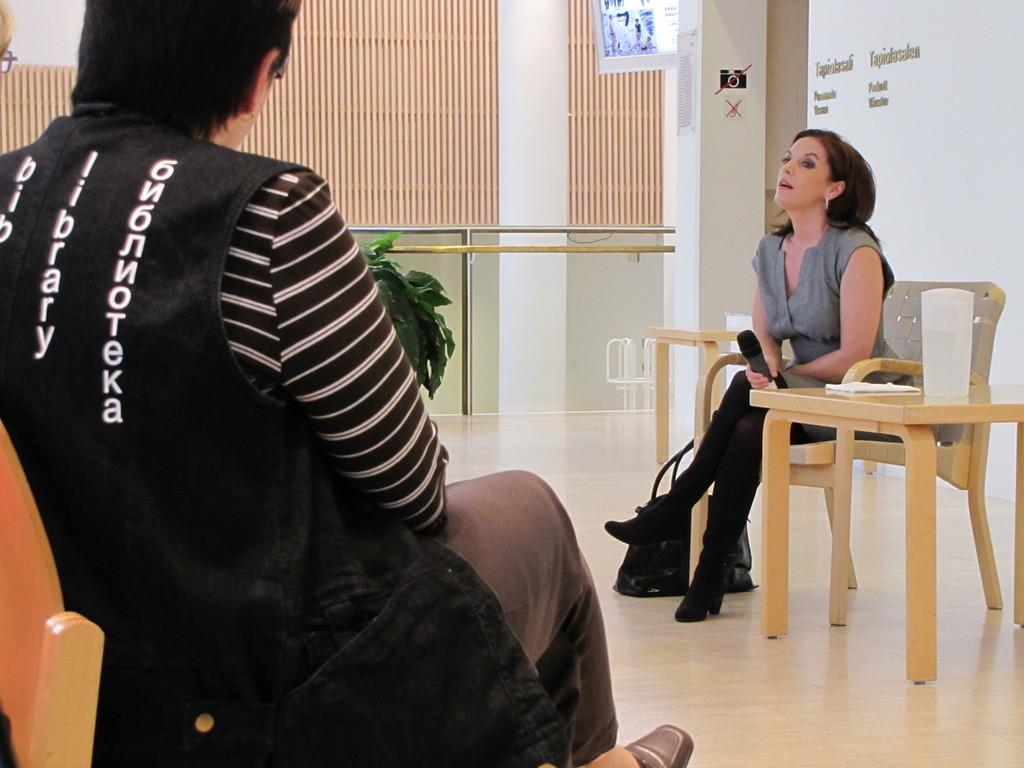What is the man doing in the image? The man is sitting in a chair on the left side of the image. What is the girl doing in the image? The girl is holding a microphone on the right side of the image. What can be seen in the middle of the image? There is a glass railing in the middle of the image. What type of orange is being used as an example in the image? There is no orange present in the image, and no examples are being used. 